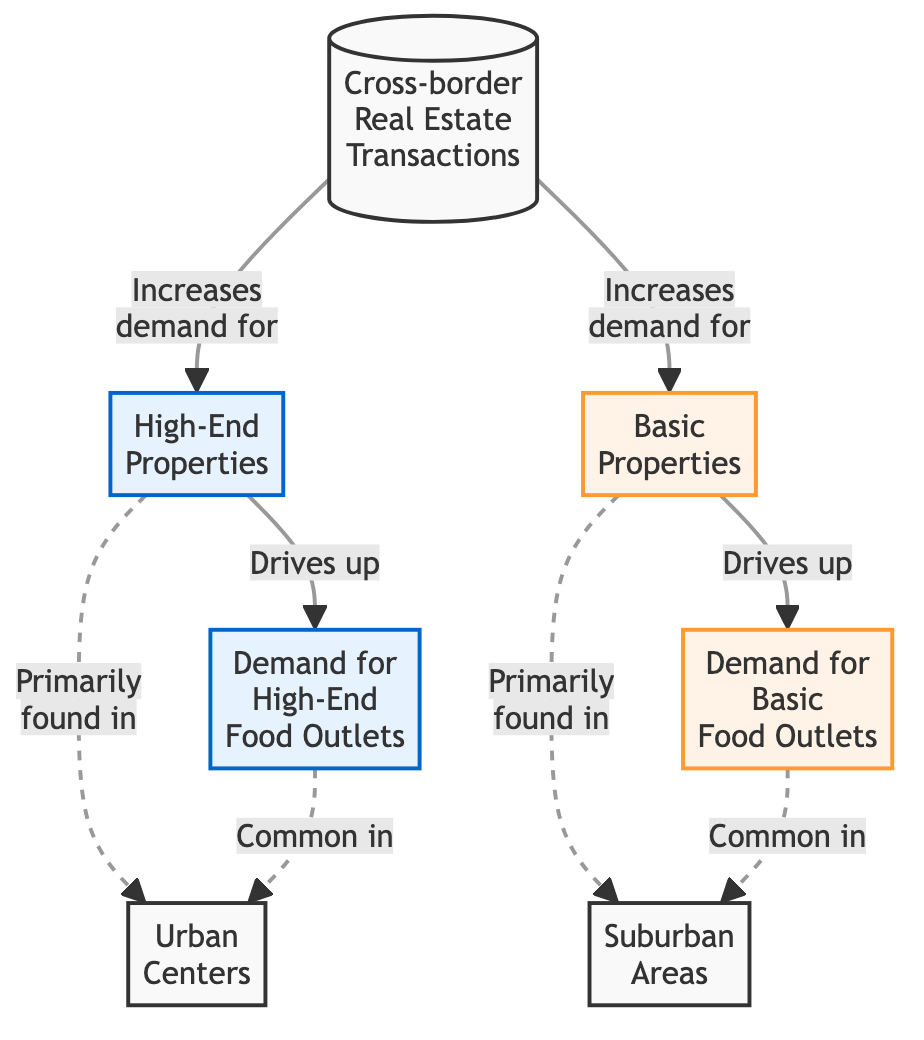What is the primary factor increasing the demand for high-end properties? The diagram shows that cross-border real estate transactions increase the demand for high-end properties.
Answer: Cross-border real estate transactions How many main property types are identified in the diagram? The diagram identifies two main property types: high-end properties and basic properties.
Answer: Two Where are high-end food outlets primarily located according to the diagram? The diagram indicates that high-end food outlets are primarily found in urban centers.
Answer: Urban centers Which type of properties drives up the demand for basic food outlets? Basic properties drive up the demand for basic food outlets as per the diagram.
Answer: Basic properties What are the two common locations mentioned for food outlets in the diagram? The diagram presents urban centers common for high-end food outlets and suburban areas for basic food outlets.
Answer: Urban centers and suburban areas What type of properties are primarily found in suburban areas? Basic properties are primarily found in suburban areas according to the diagram.
Answer: Basic properties How do cross-border real estate transactions affect the food outlet demand? Cross-border real estate transactions increase the demand for both high-end and basic food outlets, as shown in the diagram.
Answer: Increase demand What kind of relationship exists between high-end properties and high-end food outlets? The relationship is a direct causal one, where high-end properties drive up the demand for high-end food outlets.
Answer: Drives up Which property type is associated with the suburban areas? The diagram associates basic properties with suburban areas.
Answer: Basic properties How does the presence of high-end properties affect urban centers according to the diagram? The presence of high-end properties in urban centers drives up the demand for high-end food outlets.
Answer: Drives up demand 